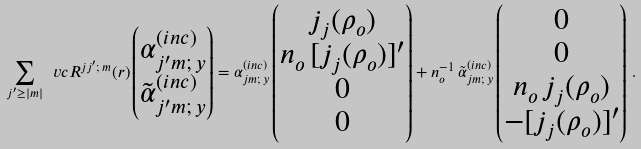Convert formula to latex. <formula><loc_0><loc_0><loc_500><loc_500>\sum _ { j ^ { \prime } \geq | m | } \ v c { R } ^ { j j ^ { \prime } ; \, m } ( r ) \begin{pmatrix} \alpha _ { j ^ { \prime } m ; \, y } ^ { ( i n c ) } \\ \tilde { \alpha } _ { j ^ { \prime } m ; \, y } ^ { ( i n c ) } \end{pmatrix} = \alpha _ { j m ; \, y } ^ { ( i n c ) } \begin{pmatrix} j _ { j } ( \rho _ { o } ) \\ n _ { o } \, [ j _ { j } ( \rho _ { o } ) ] ^ { \prime } \\ 0 \\ 0 \end{pmatrix} + n _ { o } ^ { - 1 } \, \tilde { \alpha } _ { j m ; \, y } ^ { ( i n c ) } \begin{pmatrix} 0 \\ 0 \\ n _ { o } \, j _ { j } ( \rho _ { o } ) \\ - [ j _ { j } ( \rho _ { o } ) ] ^ { \prime } \end{pmatrix} \, .</formula> 